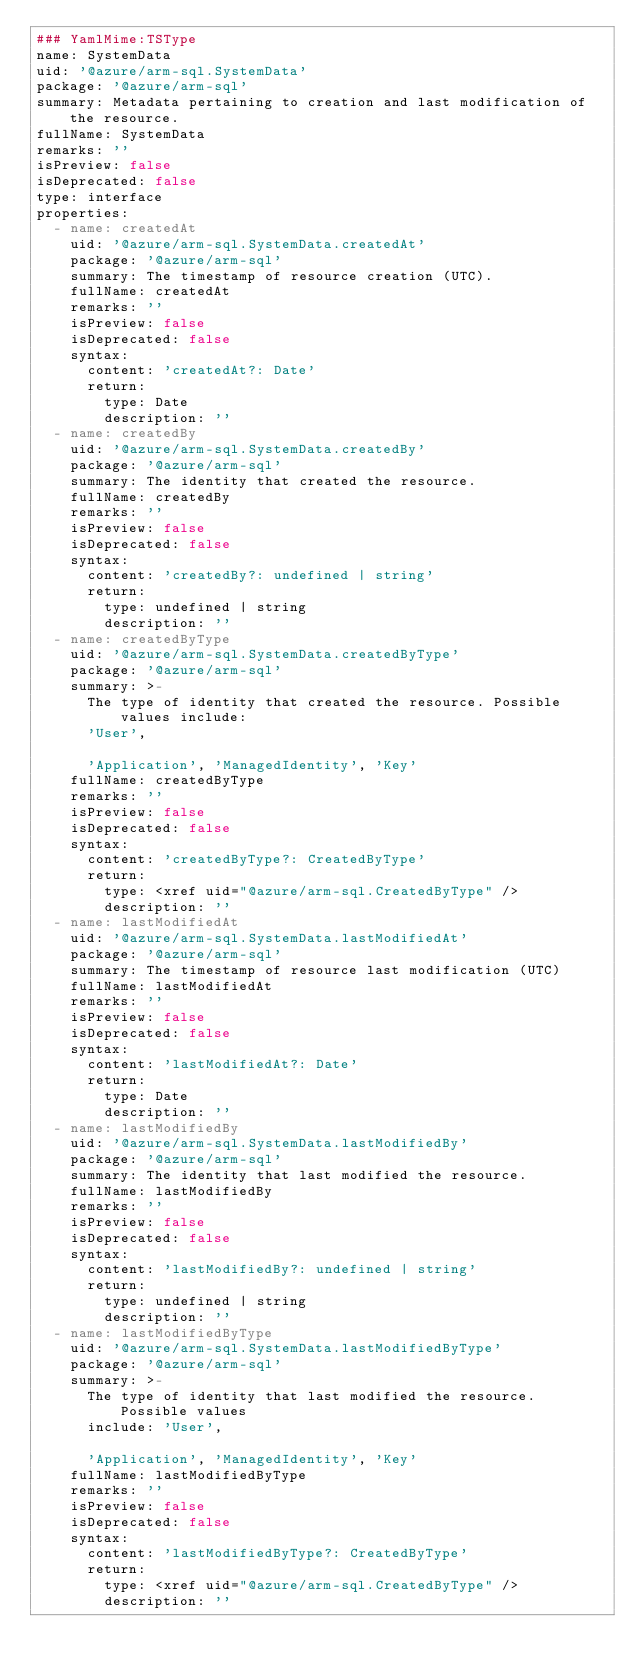Convert code to text. <code><loc_0><loc_0><loc_500><loc_500><_YAML_>### YamlMime:TSType
name: SystemData
uid: '@azure/arm-sql.SystemData'
package: '@azure/arm-sql'
summary: Metadata pertaining to creation and last modification of the resource.
fullName: SystemData
remarks: ''
isPreview: false
isDeprecated: false
type: interface
properties:
  - name: createdAt
    uid: '@azure/arm-sql.SystemData.createdAt'
    package: '@azure/arm-sql'
    summary: The timestamp of resource creation (UTC).
    fullName: createdAt
    remarks: ''
    isPreview: false
    isDeprecated: false
    syntax:
      content: 'createdAt?: Date'
      return:
        type: Date
        description: ''
  - name: createdBy
    uid: '@azure/arm-sql.SystemData.createdBy'
    package: '@azure/arm-sql'
    summary: The identity that created the resource.
    fullName: createdBy
    remarks: ''
    isPreview: false
    isDeprecated: false
    syntax:
      content: 'createdBy?: undefined | string'
      return:
        type: undefined | string
        description: ''
  - name: createdByType
    uid: '@azure/arm-sql.SystemData.createdByType'
    package: '@azure/arm-sql'
    summary: >-
      The type of identity that created the resource. Possible values include:
      'User',

      'Application', 'ManagedIdentity', 'Key'
    fullName: createdByType
    remarks: ''
    isPreview: false
    isDeprecated: false
    syntax:
      content: 'createdByType?: CreatedByType'
      return:
        type: <xref uid="@azure/arm-sql.CreatedByType" />
        description: ''
  - name: lastModifiedAt
    uid: '@azure/arm-sql.SystemData.lastModifiedAt'
    package: '@azure/arm-sql'
    summary: The timestamp of resource last modification (UTC)
    fullName: lastModifiedAt
    remarks: ''
    isPreview: false
    isDeprecated: false
    syntax:
      content: 'lastModifiedAt?: Date'
      return:
        type: Date
        description: ''
  - name: lastModifiedBy
    uid: '@azure/arm-sql.SystemData.lastModifiedBy'
    package: '@azure/arm-sql'
    summary: The identity that last modified the resource.
    fullName: lastModifiedBy
    remarks: ''
    isPreview: false
    isDeprecated: false
    syntax:
      content: 'lastModifiedBy?: undefined | string'
      return:
        type: undefined | string
        description: ''
  - name: lastModifiedByType
    uid: '@azure/arm-sql.SystemData.lastModifiedByType'
    package: '@azure/arm-sql'
    summary: >-
      The type of identity that last modified the resource. Possible values
      include: 'User',

      'Application', 'ManagedIdentity', 'Key'
    fullName: lastModifiedByType
    remarks: ''
    isPreview: false
    isDeprecated: false
    syntax:
      content: 'lastModifiedByType?: CreatedByType'
      return:
        type: <xref uid="@azure/arm-sql.CreatedByType" />
        description: ''
</code> 